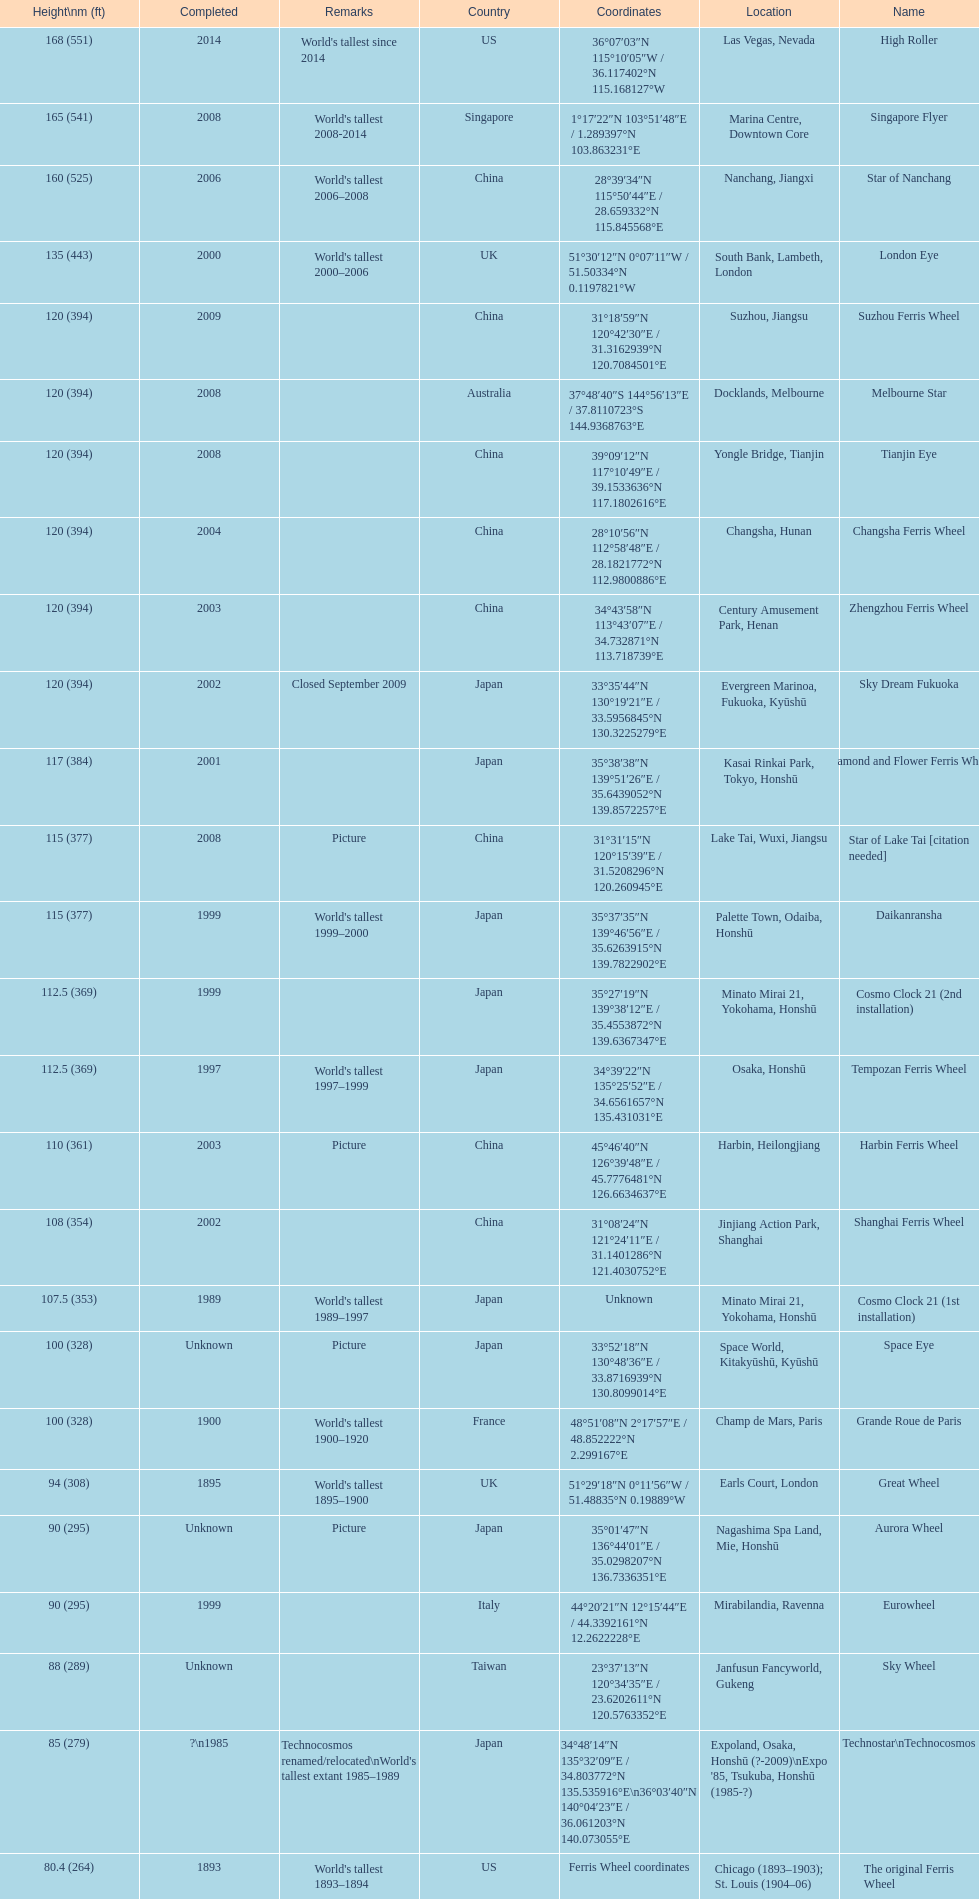How tall is the roller coaster star of nanchang? 165 (541). When was the roller coaster star of nanchang completed? 2008. What is the name of the oldest roller coaster? Star of Nanchang. 